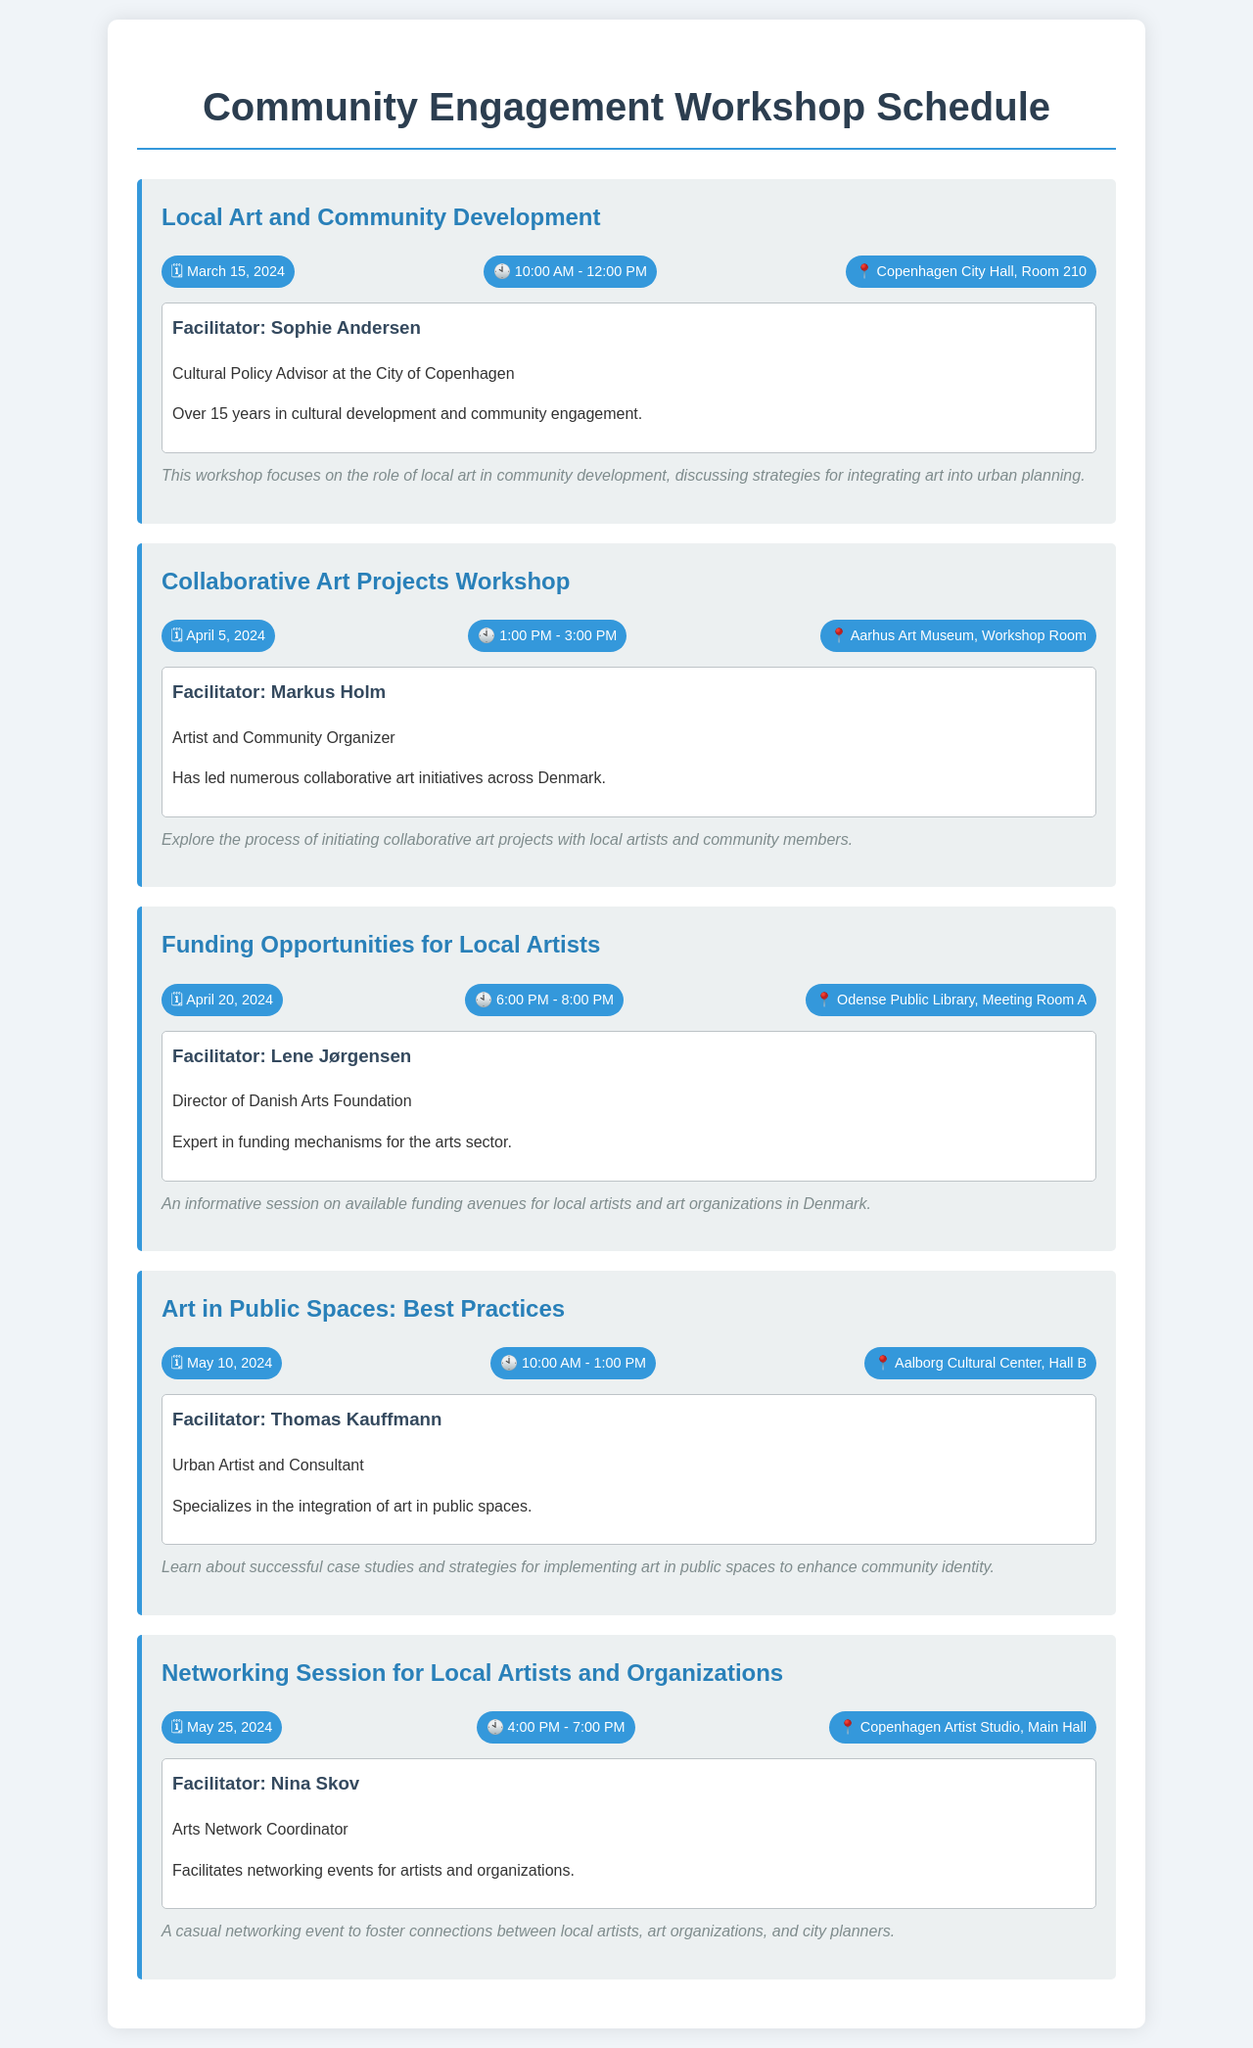What is the title of the first workshop? The title of the first workshop is found in the document's section detailing the workshops.
Answer: Local Art and Community Development When is the workshop on funding opportunities scheduled? The specific date for the workshop on funding opportunities is listed in the document.
Answer: April 20, 2024 Who is facilitating the workshop on art in public spaces? The facilitator's name for that workshop is mentioned in the document.
Answer: Thomas Kauffmann What time does the networking session start? The start time for the networking session is specified in the schedule.
Answer: 4:00 PM Which location hosts the collaborative art projects workshop? The document identifies the location of that workshop.
Answer: Aarhus Art Museum, Workshop Room What is the duration of the workshop on local art and community development? The duration can be calculated from the start and end times listed in the document.
Answer: 2 hours How many workshops are scheduled in total? The total number of workshops is counted from the document’s content.
Answer: 5 What is the focus of the funding opportunities workshop? The theme of that workshop is provided in the description section.
Answer: Available funding avenues for local artists and art organizations in Denmark 